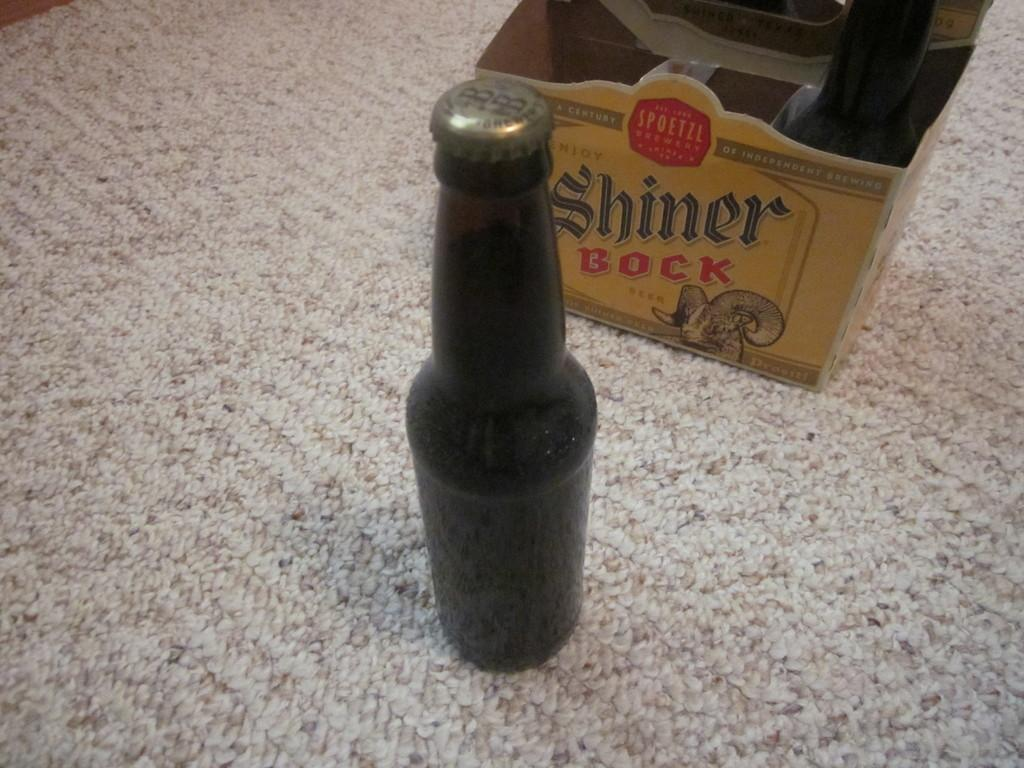<image>
Describe the image concisely. a box of shiner bock behind a bottle of it 